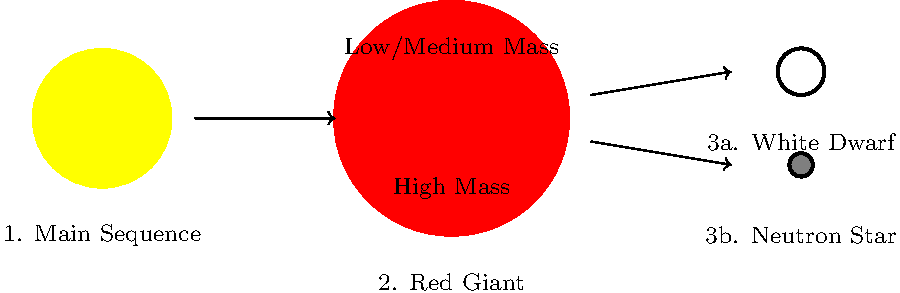Based on the diagram depicting the life cycle of stars, which stage represents the most extreme environment in terms of density and potential impact on spacetime, and how might this relate to cognitive processes if a human brain were to experience such conditions? To answer this question, let's analyze the stages of stellar evolution shown in the diagram:

1. Main Sequence: This is the stable phase of a star's life, where nuclear fusion of hydrogen occurs in the core. Conditions are relatively stable and not extreme.

2. Red Giant: As the star exhausts its core hydrogen, it expands and cools. While larger, it's less dense than the main sequence stage.

3a. White Dwarf: For low to medium mass stars, this is the end stage. White dwarfs are very dense, with matter in a degenerate state.

3b. Neutron Star: This is the end stage for high-mass stars. Neutron stars represent an extreme environment due to their incredible density and strong gravitational field.

Comparing these stages:

- Neutron stars have the highest density, with all protons and electrons crushed together to form neutrons.
- Their gravity is so strong that it significantly warps spacetime around them.
- The surface gravity of a neutron star is about $10^{11}$ times that of Earth.
- Neutron stars can have magnetic fields $10^8$ to $10^{15}$ times stronger than Earth's.

From a cognitive neuroscience perspective:

- Such extreme gravity would cause immediate physical destruction of brain tissue.
- The intense magnetic fields could dramatically interfere with neural signaling, which relies on ion movements and electrical impulses.
- Time dilation effects near a neutron star would cause significant discrepancies between cognitive processes and the passage of time in the outside universe.
- The extreme density might theoretically compress information to quantum scales, potentially relating to quantum theories of consciousness.

Therefore, the neutron star stage represents the most extreme environment with the most profound theoretical implications for cognitive processes.
Answer: Neutron star stage 